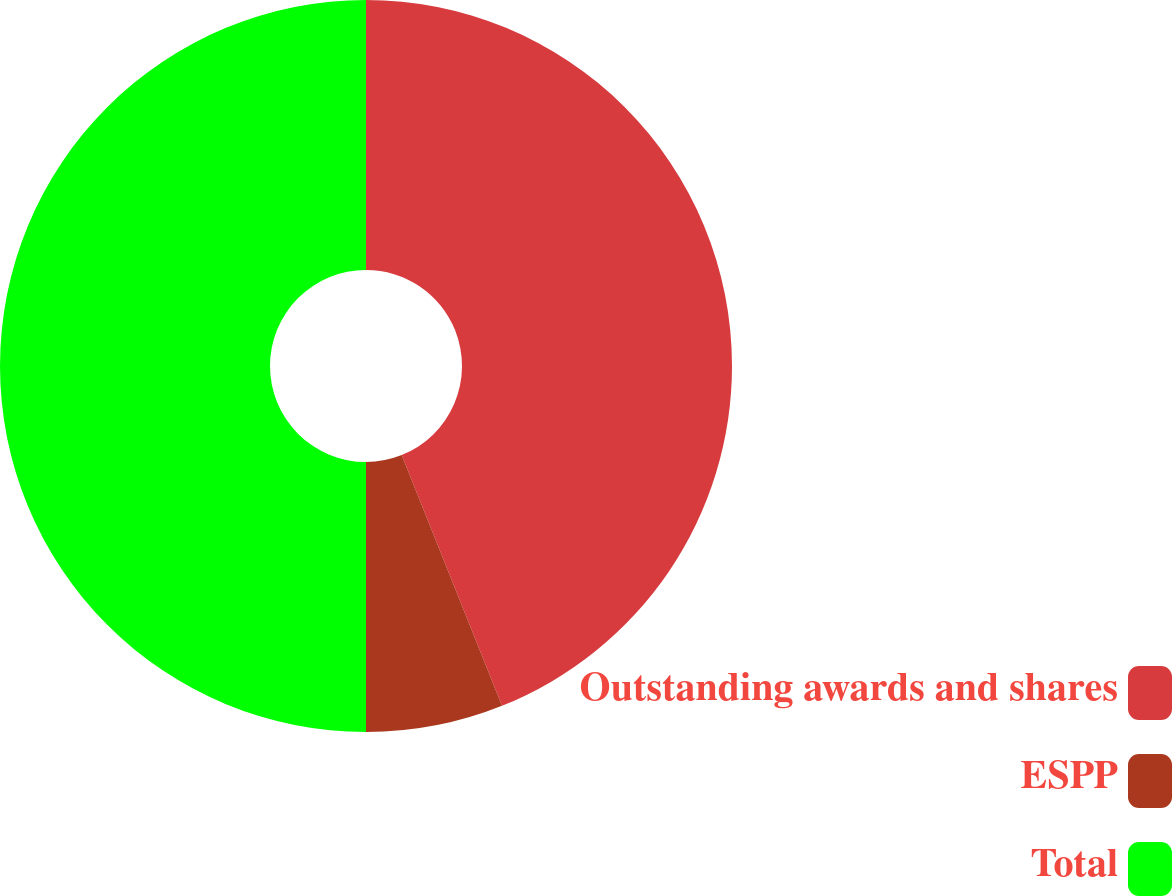Convert chart. <chart><loc_0><loc_0><loc_500><loc_500><pie_chart><fcel>Outstanding awards and shares<fcel>ESPP<fcel>Total<nl><fcel>43.94%<fcel>6.06%<fcel>50.0%<nl></chart> 